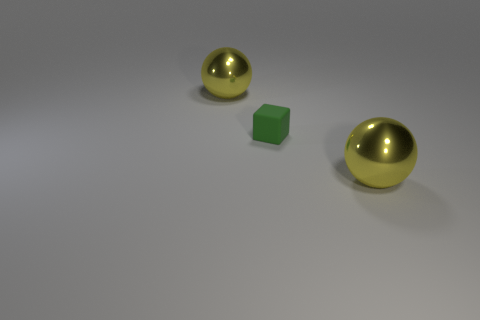There is a green matte thing that is right of the shiny sphere that is left of the block; what size is it?
Provide a succinct answer. Small. Are there more yellow balls that are on the right side of the small green rubber cube than small cyan rubber objects?
Your answer should be compact. Yes. Is there a matte cylinder that has the same color as the rubber block?
Offer a terse response. No. Are there an equal number of rubber cubes that are left of the cube and big red matte things?
Give a very brief answer. Yes. What number of yellow things have the same material as the green object?
Offer a very short reply. 0. Are there any other things that have the same shape as the green matte object?
Your response must be concise. No. What is the color of the shiny ball that is on the left side of the large yellow thing in front of the yellow ball that is behind the green object?
Give a very brief answer. Yellow. Are there any other things that are the same size as the block?
Your response must be concise. No. The rubber thing has what color?
Provide a short and direct response. Green. What shape is the green rubber object that is to the left of the big yellow object in front of the sphere that is behind the small green thing?
Offer a very short reply. Cube. 